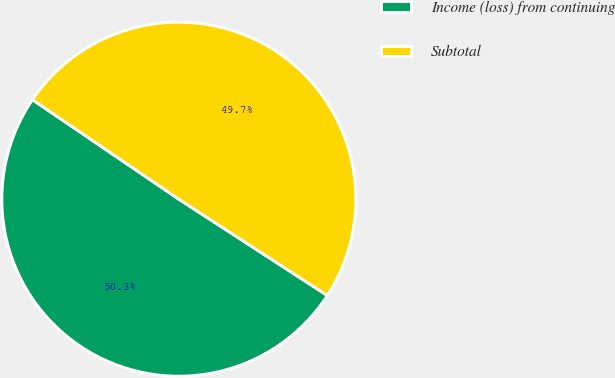<chart> <loc_0><loc_0><loc_500><loc_500><pie_chart><fcel>Income (loss) from continuing<fcel>Subtotal<nl><fcel>50.34%<fcel>49.66%<nl></chart> 